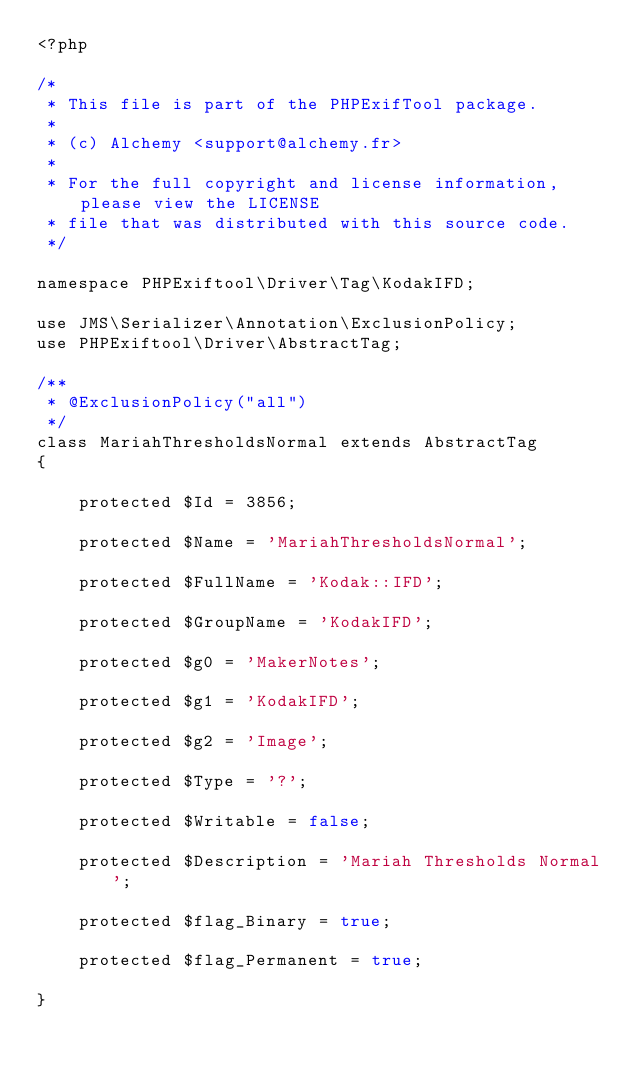Convert code to text. <code><loc_0><loc_0><loc_500><loc_500><_PHP_><?php

/*
 * This file is part of the PHPExifTool package.
 *
 * (c) Alchemy <support@alchemy.fr>
 *
 * For the full copyright and license information, please view the LICENSE
 * file that was distributed with this source code.
 */

namespace PHPExiftool\Driver\Tag\KodakIFD;

use JMS\Serializer\Annotation\ExclusionPolicy;
use PHPExiftool\Driver\AbstractTag;

/**
 * @ExclusionPolicy("all")
 */
class MariahThresholdsNormal extends AbstractTag
{

    protected $Id = 3856;

    protected $Name = 'MariahThresholdsNormal';

    protected $FullName = 'Kodak::IFD';

    protected $GroupName = 'KodakIFD';

    protected $g0 = 'MakerNotes';

    protected $g1 = 'KodakIFD';

    protected $g2 = 'Image';

    protected $Type = '?';

    protected $Writable = false;

    protected $Description = 'Mariah Thresholds Normal';

    protected $flag_Binary = true;

    protected $flag_Permanent = true;

}
</code> 